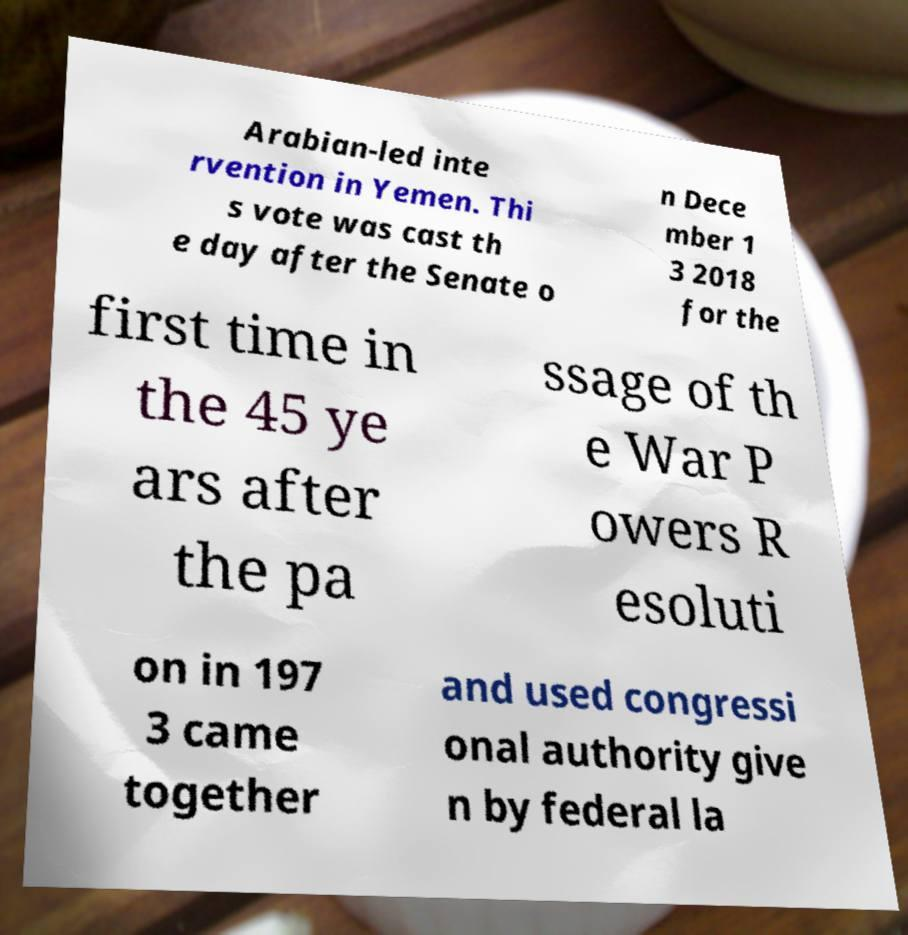For documentation purposes, I need the text within this image transcribed. Could you provide that? Arabian-led inte rvention in Yemen. Thi s vote was cast th e day after the Senate o n Dece mber 1 3 2018 for the first time in the 45 ye ars after the pa ssage of th e War P owers R esoluti on in 197 3 came together and used congressi onal authority give n by federal la 